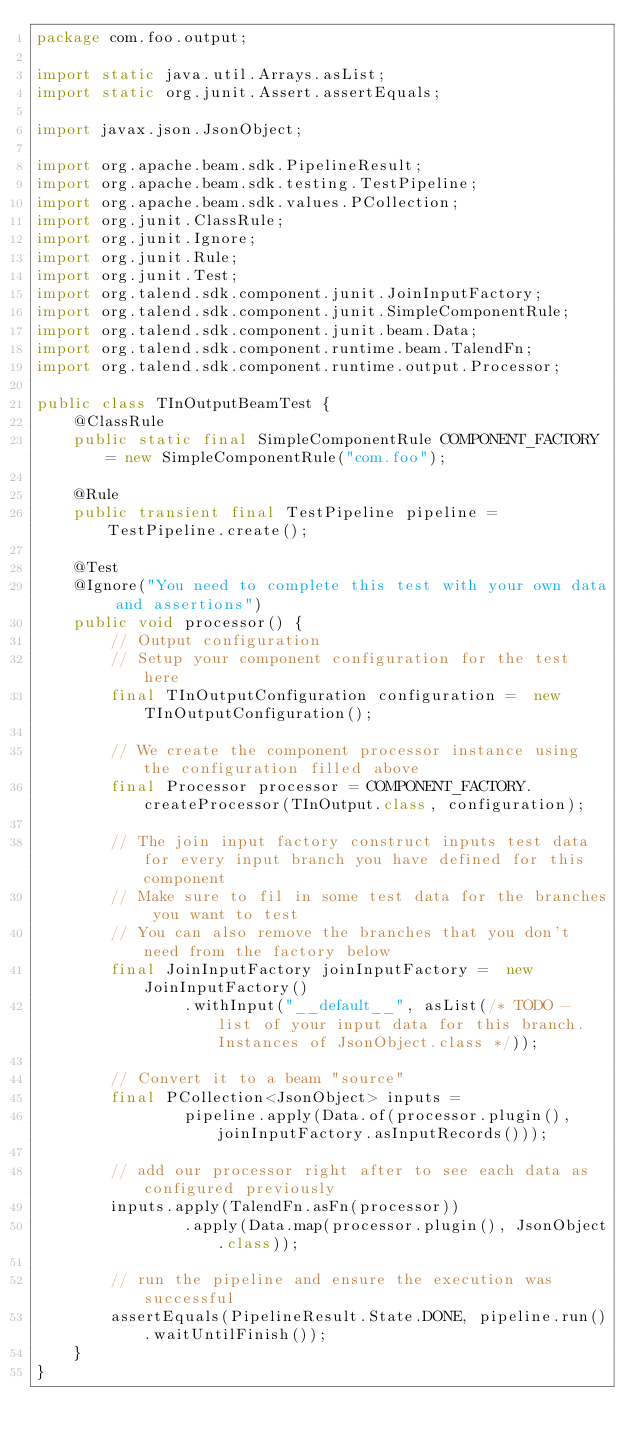<code> <loc_0><loc_0><loc_500><loc_500><_Java_>package com.foo.output;

import static java.util.Arrays.asList;
import static org.junit.Assert.assertEquals;

import javax.json.JsonObject;

import org.apache.beam.sdk.PipelineResult;
import org.apache.beam.sdk.testing.TestPipeline;
import org.apache.beam.sdk.values.PCollection;
import org.junit.ClassRule;
import org.junit.Ignore;
import org.junit.Rule;
import org.junit.Test;
import org.talend.sdk.component.junit.JoinInputFactory;
import org.talend.sdk.component.junit.SimpleComponentRule;
import org.talend.sdk.component.junit.beam.Data;
import org.talend.sdk.component.runtime.beam.TalendFn;
import org.talend.sdk.component.runtime.output.Processor;

public class TInOutputBeamTest {
    @ClassRule
    public static final SimpleComponentRule COMPONENT_FACTORY = new SimpleComponentRule("com.foo");

    @Rule
    public transient final TestPipeline pipeline = TestPipeline.create();

    @Test
    @Ignore("You need to complete this test with your own data and assertions")
    public void processor() {
        // Output configuration
        // Setup your component configuration for the test here
        final TInOutputConfiguration configuration =  new TInOutputConfiguration();

        // We create the component processor instance using the configuration filled above
        final Processor processor = COMPONENT_FACTORY.createProcessor(TInOutput.class, configuration);

        // The join input factory construct inputs test data for every input branch you have defined for this component
        // Make sure to fil in some test data for the branches you want to test
        // You can also remove the branches that you don't need from the factory below
        final JoinInputFactory joinInputFactory =  new JoinInputFactory()
                .withInput("__default__", asList(/* TODO - list of your input data for this branch. Instances of JsonObject.class */));

        // Convert it to a beam "source"
        final PCollection<JsonObject> inputs =
                pipeline.apply(Data.of(processor.plugin(), joinInputFactory.asInputRecords()));

        // add our processor right after to see each data as configured previously
        inputs.apply(TalendFn.asFn(processor))
                .apply(Data.map(processor.plugin(), JsonObject.class));

        // run the pipeline and ensure the execution was successful
        assertEquals(PipelineResult.State.DONE, pipeline.run().waitUntilFinish());
    }
}</code> 